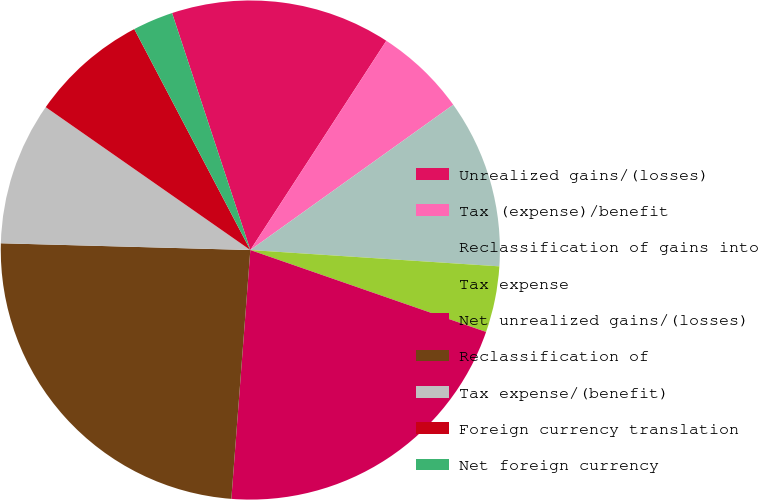Convert chart to OTSL. <chart><loc_0><loc_0><loc_500><loc_500><pie_chart><fcel>Unrealized gains/(losses)<fcel>Tax (expense)/benefit<fcel>Reclassification of gains into<fcel>Tax expense<fcel>Net unrealized gains/(losses)<fcel>Reclassification of<fcel>Tax expense/(benefit)<fcel>Foreign currency translation<fcel>Net foreign currency<nl><fcel>14.25%<fcel>5.94%<fcel>10.93%<fcel>4.28%<fcel>20.89%<fcel>24.22%<fcel>9.27%<fcel>7.6%<fcel>2.62%<nl></chart> 